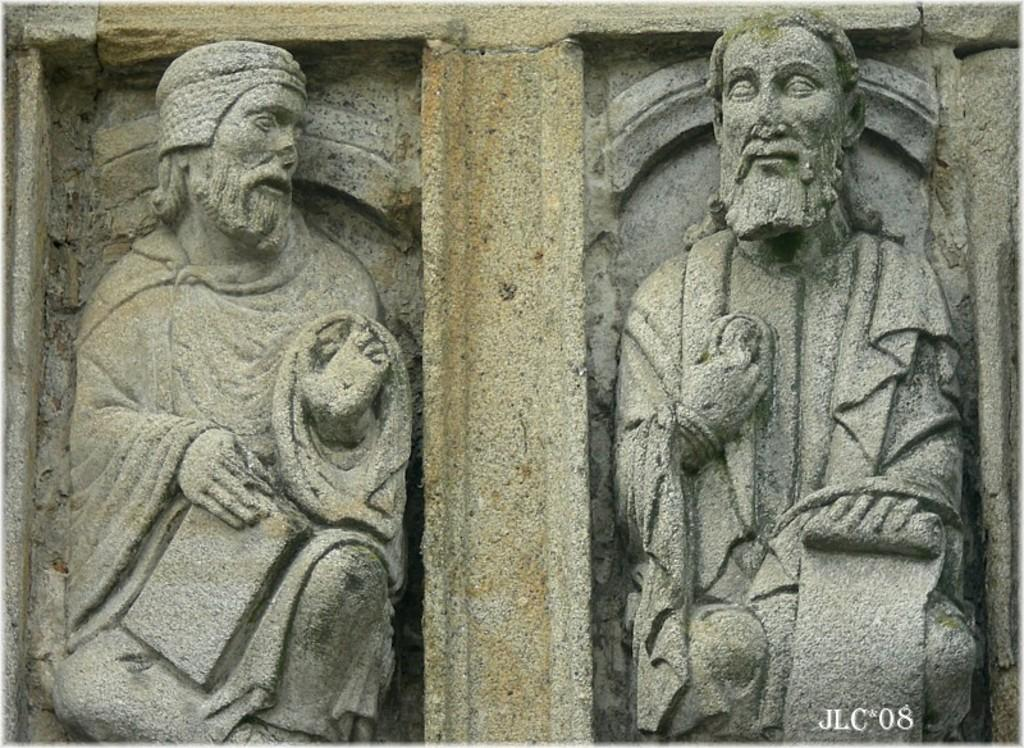How many statues of a man are present in the image? There are two statues of a man in the image. Can you describe the location of the watermark in the image? The watermark is in the right-hand side bottom of the image. What type of guitar is the actor playing in the image? There is no guitar or actor present in the image; it only features two statues of a man and a watermark. 